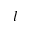<formula> <loc_0><loc_0><loc_500><loc_500>l</formula> 